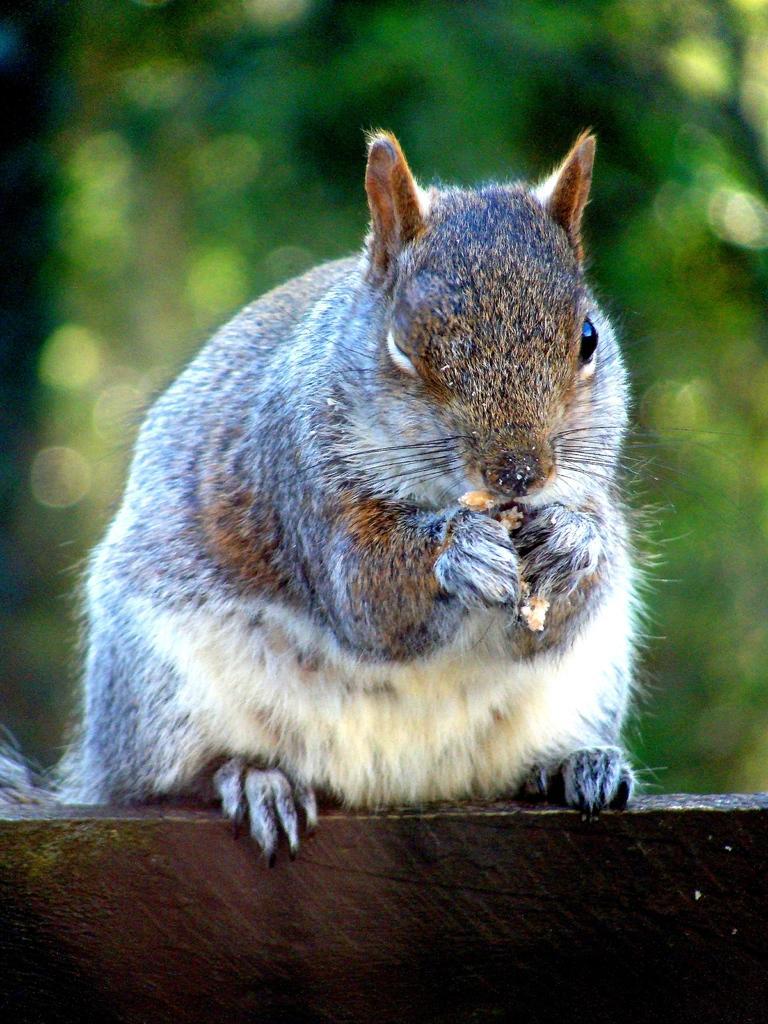How would you summarize this image in a sentence or two? In this image there is a squirrel holding food, the background of the squirrel is green. 